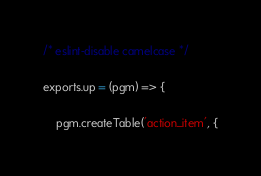<code> <loc_0><loc_0><loc_500><loc_500><_JavaScript_>/* eslint-disable camelcase */

exports.up = (pgm) => {

    pgm.createTable('action_item', {</code> 